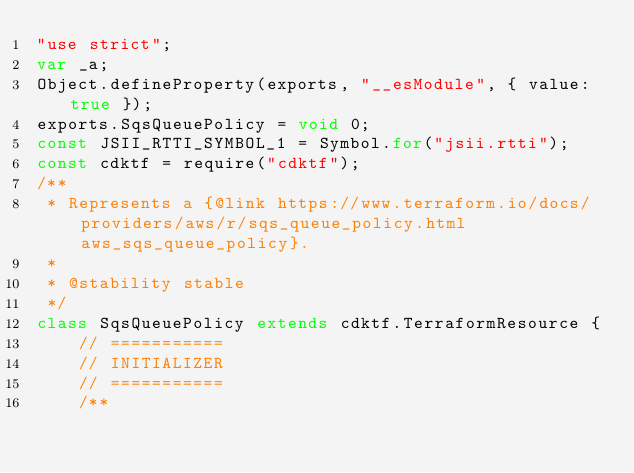<code> <loc_0><loc_0><loc_500><loc_500><_JavaScript_>"use strict";
var _a;
Object.defineProperty(exports, "__esModule", { value: true });
exports.SqsQueuePolicy = void 0;
const JSII_RTTI_SYMBOL_1 = Symbol.for("jsii.rtti");
const cdktf = require("cdktf");
/**
 * Represents a {@link https://www.terraform.io/docs/providers/aws/r/sqs_queue_policy.html aws_sqs_queue_policy}.
 *
 * @stability stable
 */
class SqsQueuePolicy extends cdktf.TerraformResource {
    // ===========
    // INITIALIZER
    // ===========
    /**</code> 